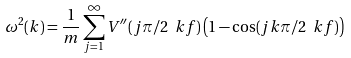<formula> <loc_0><loc_0><loc_500><loc_500>\omega ^ { 2 } ( k ) = \frac { 1 } { m } \sum _ { j = 1 } ^ { \infty } V ^ { \prime \prime } ( j \pi / 2 \ k f ) \left ( 1 - \cos ( j k \pi / 2 \ k f ) \right )</formula> 